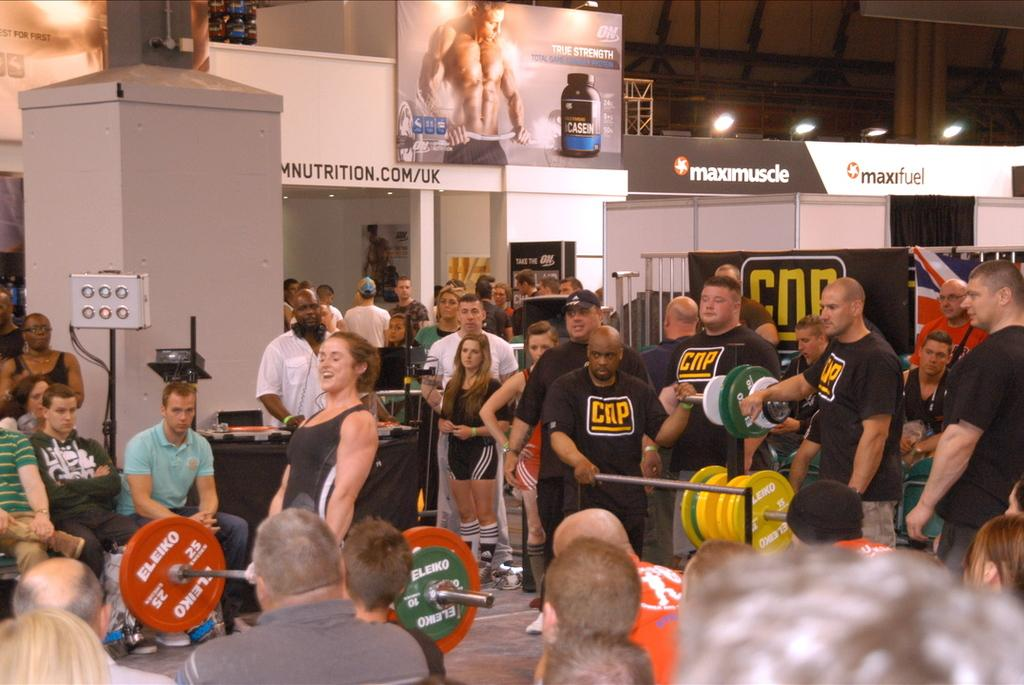How many people are in the image? There is a group of people in the image. What is one person in the group doing? There is a person holding a dumbbell in the image. What can be seen in the background of the image? Name boards, focus lights, lighting truss, iron grills, and banners are visible in the background of the image. How many babies are crawling on the floor in the image? There are no babies present in the image. What type of pump is being used by the person holding the dumbbell? The person holding the dumbbell is not using a pump in the image. 